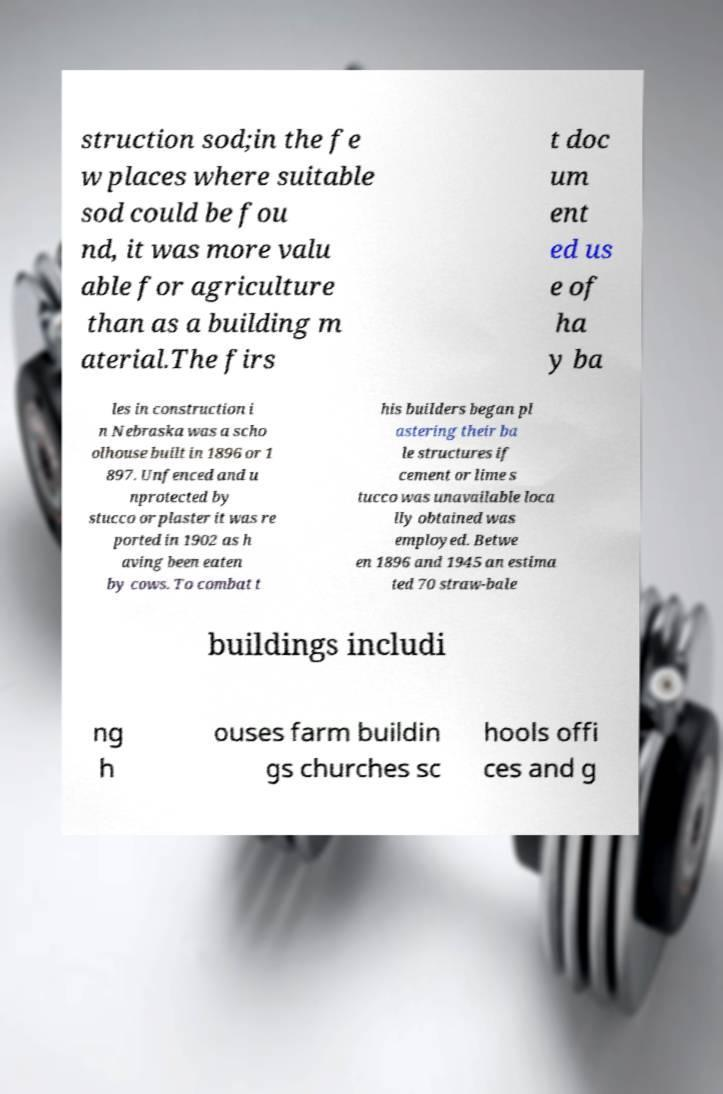I need the written content from this picture converted into text. Can you do that? struction sod;in the fe w places where suitable sod could be fou nd, it was more valu able for agriculture than as a building m aterial.The firs t doc um ent ed us e of ha y ba les in construction i n Nebraska was a scho olhouse built in 1896 or 1 897. Unfenced and u nprotected by stucco or plaster it was re ported in 1902 as h aving been eaten by cows. To combat t his builders began pl astering their ba le structures if cement or lime s tucco was unavailable loca lly obtained was employed. Betwe en 1896 and 1945 an estima ted 70 straw-bale buildings includi ng h ouses farm buildin gs churches sc hools offi ces and g 